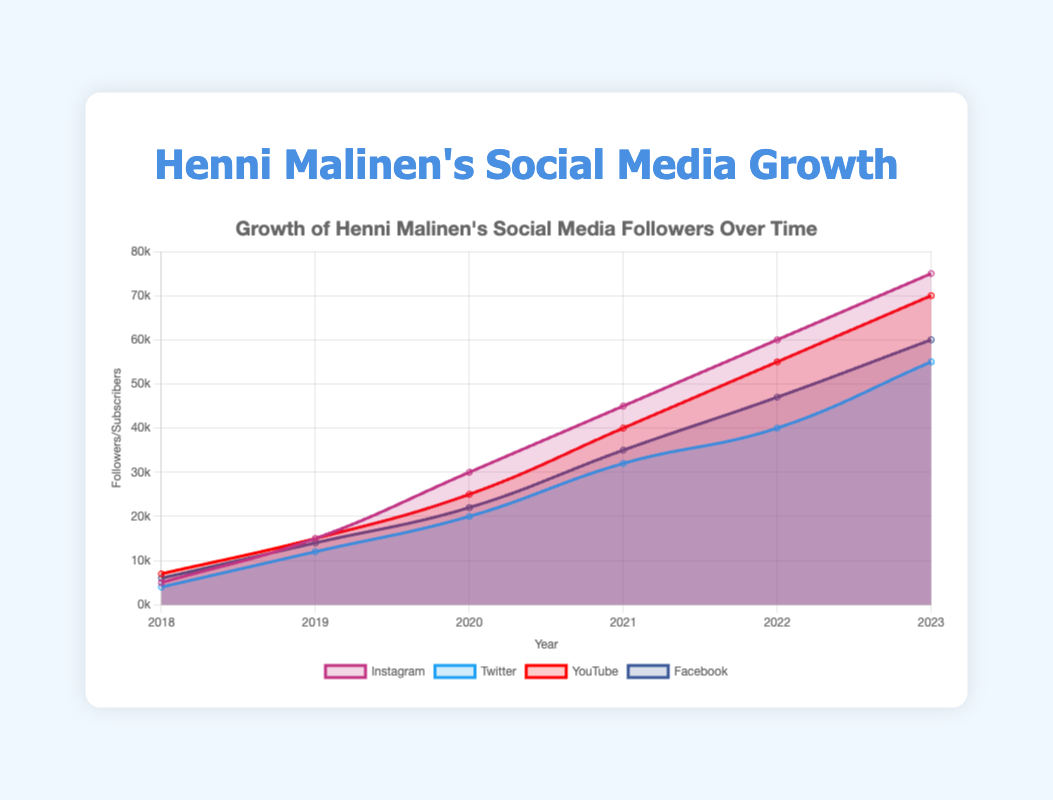What is the platform with the highest number of followers in 2023? The figure shows the follower counts for all platforms in 2023. By inspecting the highest data point on the y-axis for 2023, Instagram has the highest count with 75,000 followers.
Answer: Instagram Which platform started with the highest follower count in 2018? To determine the highest follower count in 2018, compare the values across all platforms: Instagram (5000), Twitter (4000), YouTube (7000), and Facebook (6000). YouTube had the highest initial count with 7,000 subscribers.
Answer: YouTube By how many followers did Instagram's followers grow from 2018 to 2019? Subtract Instagram's followers in 2018 from those in 2019: 15,000 (2019) - 5,000 (2018) = 10,000.
Answer: 10,000 Which platform experienced the least growth between 2018 and 2023? Calculate the growth for each platform by subtracting their 2018 values from their 2023 values: Instagram (75,000 - 5,000 = 70,000), Twitter (55,000 - 4,000 = 51,000), YouTube (70,000 - 7,000 = 63,000), Facebook (60,000 - 6,000 = 54,000). Twitter experienced the least growth with 51,000 followers gained.
Answer: Twitter Did Facebook's followers ever surpass YouTube's subscribers over the given time period? Compare the lines representing Facebook and YouTube over the years from 2018 to 2023. The lines of Facebook (blue) and YouTube (red) do not cross each other at any point, so Facebook's followers never surpassed YouTube's subscribers.
Answer: No Which year saw the highest increase in followers for Twitter? Examine the slope of the Twitter line (light blue) between each pair of consecutive years. The largest jump is between 2018 and 2019, when the follower count increased from 4,000 to 12,000: 12,000 - 4,000 = 8,000 increase.
Answer: 2019 What is the combined total for followers/subscribers across all platforms in 2023? Sum the follower counts for all platforms in 2023: Instagram (75,000), Twitter (55,000), YouTube (70,000), Facebook (60,000). Total = 75,000 + 55,000 + 70,000 + 60,000 = 260,000.
Answer: 260,000 In which year did Henni Malinen's social media presence reach 100,000 followers/subscribers in total across all platforms? Calculate the combined total for each year until the sum reaches or exceeds 100,000: 
- 2018: 5,000 (Instagram) + 4,000 (Twitter) + 7,000 (YouTube) + 6,000 (Facebook) = 22,000
- 2019: 15,000 (Instagram) + 12,000 (Twitter) + 15,000 (YouTube) + 14,000 (Facebook) = 56,000
- 2020: 30,000 (Instagram) + 20,000 (Twitter) + 25,000 (YouTube) + 22,000 (Facebook) = 97,000
- 2021: 45,000 (Instagram) + 32,000 (Twitter) + 40,000 (YouTube) + 35,000 (Facebook) = 152,000
The combined total surpasses 100,000 in 2021.
Answer: 2021 Comparing Instagram and Facebook, which platform had a steeper growth rate between 2020 and 2021? Calculate the growth rate by determining the difference in followers between the two years for each platform and then comparing the magnitudes: 
- Instagram: 45,000 (2021) - 30,000 (2020) = 15,000
- Facebook: 35,000 (2021) - 22,000 (2020) = 13,000
Instagram had a steeper growth rate with an increase of 15,000 followers.
Answer: Instagram 